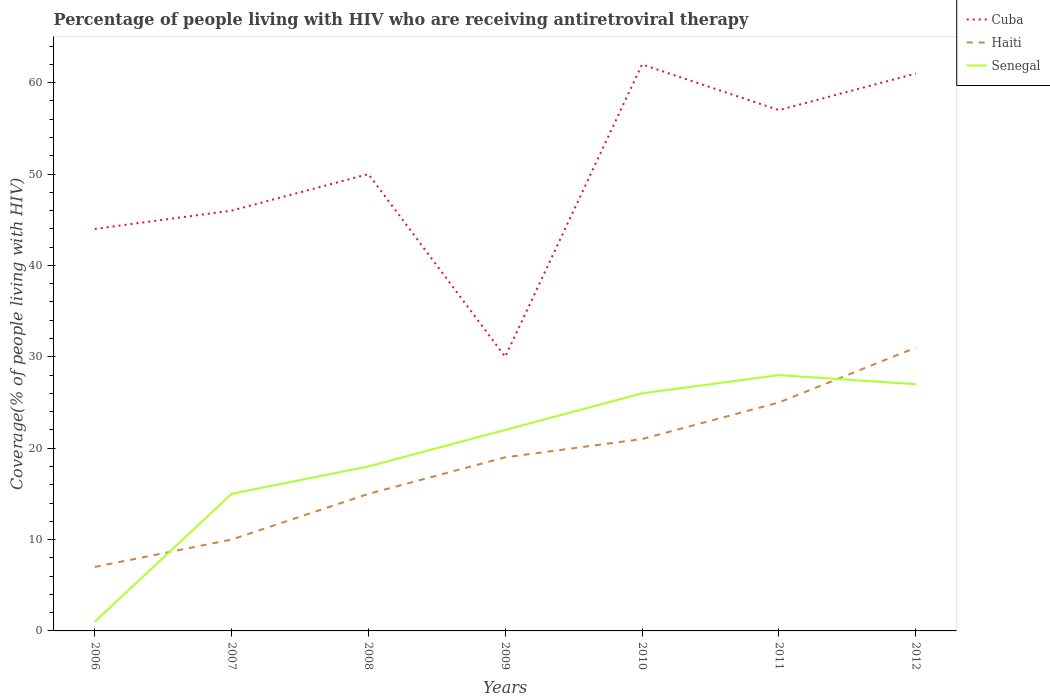Is the number of lines equal to the number of legend labels?
Offer a terse response. Yes. Across all years, what is the maximum percentage of the HIV infected people who are receiving antiretroviral therapy in Haiti?
Offer a very short reply. 7. In which year was the percentage of the HIV infected people who are receiving antiretroviral therapy in Haiti maximum?
Your answer should be compact. 2006. What is the total percentage of the HIV infected people who are receiving antiretroviral therapy in Haiti in the graph?
Provide a succinct answer. -12. What is the difference between the highest and the second highest percentage of the HIV infected people who are receiving antiretroviral therapy in Haiti?
Offer a terse response. 24. Is the percentage of the HIV infected people who are receiving antiretroviral therapy in Cuba strictly greater than the percentage of the HIV infected people who are receiving antiretroviral therapy in Senegal over the years?
Your response must be concise. No. Does the graph contain any zero values?
Provide a succinct answer. No. Does the graph contain grids?
Ensure brevity in your answer.  No. How are the legend labels stacked?
Your answer should be compact. Vertical. What is the title of the graph?
Keep it short and to the point. Percentage of people living with HIV who are receiving antiretroviral therapy. What is the label or title of the Y-axis?
Keep it short and to the point. Coverage(% of people living with HIV). What is the Coverage(% of people living with HIV) of Haiti in 2006?
Your answer should be compact. 7. What is the Coverage(% of people living with HIV) of Senegal in 2007?
Your answer should be very brief. 15. What is the Coverage(% of people living with HIV) of Cuba in 2008?
Offer a very short reply. 50. What is the Coverage(% of people living with HIV) of Haiti in 2008?
Ensure brevity in your answer.  15. What is the Coverage(% of people living with HIV) of Senegal in 2008?
Give a very brief answer. 18. What is the Coverage(% of people living with HIV) in Senegal in 2009?
Your answer should be very brief. 22. What is the Coverage(% of people living with HIV) in Haiti in 2010?
Provide a short and direct response. 21. What is the Coverage(% of people living with HIV) in Cuba in 2011?
Provide a short and direct response. 57. What is the Coverage(% of people living with HIV) in Haiti in 2011?
Keep it short and to the point. 25. What is the Coverage(% of people living with HIV) in Haiti in 2012?
Offer a very short reply. 31. Across all years, what is the maximum Coverage(% of people living with HIV) of Cuba?
Ensure brevity in your answer.  62. Across all years, what is the maximum Coverage(% of people living with HIV) in Senegal?
Provide a short and direct response. 28. Across all years, what is the minimum Coverage(% of people living with HIV) in Cuba?
Ensure brevity in your answer.  30. Across all years, what is the minimum Coverage(% of people living with HIV) in Haiti?
Give a very brief answer. 7. What is the total Coverage(% of people living with HIV) in Cuba in the graph?
Keep it short and to the point. 350. What is the total Coverage(% of people living with HIV) in Haiti in the graph?
Give a very brief answer. 128. What is the total Coverage(% of people living with HIV) of Senegal in the graph?
Your response must be concise. 137. What is the difference between the Coverage(% of people living with HIV) in Senegal in 2006 and that in 2009?
Keep it short and to the point. -21. What is the difference between the Coverage(% of people living with HIV) in Haiti in 2006 and that in 2011?
Make the answer very short. -18. What is the difference between the Coverage(% of people living with HIV) in Cuba in 2006 and that in 2012?
Your response must be concise. -17. What is the difference between the Coverage(% of people living with HIV) of Senegal in 2006 and that in 2012?
Make the answer very short. -26. What is the difference between the Coverage(% of people living with HIV) in Haiti in 2007 and that in 2008?
Your answer should be compact. -5. What is the difference between the Coverage(% of people living with HIV) in Haiti in 2007 and that in 2009?
Your answer should be very brief. -9. What is the difference between the Coverage(% of people living with HIV) of Haiti in 2007 and that in 2010?
Give a very brief answer. -11. What is the difference between the Coverage(% of people living with HIV) of Haiti in 2007 and that in 2011?
Offer a very short reply. -15. What is the difference between the Coverage(% of people living with HIV) of Senegal in 2007 and that in 2011?
Offer a very short reply. -13. What is the difference between the Coverage(% of people living with HIV) in Cuba in 2007 and that in 2012?
Give a very brief answer. -15. What is the difference between the Coverage(% of people living with HIV) of Haiti in 2007 and that in 2012?
Your answer should be very brief. -21. What is the difference between the Coverage(% of people living with HIV) in Senegal in 2007 and that in 2012?
Keep it short and to the point. -12. What is the difference between the Coverage(% of people living with HIV) of Haiti in 2008 and that in 2009?
Give a very brief answer. -4. What is the difference between the Coverage(% of people living with HIV) of Senegal in 2008 and that in 2009?
Offer a terse response. -4. What is the difference between the Coverage(% of people living with HIV) of Cuba in 2008 and that in 2010?
Provide a succinct answer. -12. What is the difference between the Coverage(% of people living with HIV) of Haiti in 2008 and that in 2010?
Your answer should be very brief. -6. What is the difference between the Coverage(% of people living with HIV) in Senegal in 2008 and that in 2010?
Make the answer very short. -8. What is the difference between the Coverage(% of people living with HIV) in Cuba in 2008 and that in 2011?
Your answer should be very brief. -7. What is the difference between the Coverage(% of people living with HIV) of Senegal in 2008 and that in 2011?
Offer a very short reply. -10. What is the difference between the Coverage(% of people living with HIV) of Haiti in 2008 and that in 2012?
Your answer should be very brief. -16. What is the difference between the Coverage(% of people living with HIV) in Senegal in 2008 and that in 2012?
Give a very brief answer. -9. What is the difference between the Coverage(% of people living with HIV) in Cuba in 2009 and that in 2010?
Ensure brevity in your answer.  -32. What is the difference between the Coverage(% of people living with HIV) of Haiti in 2009 and that in 2010?
Make the answer very short. -2. What is the difference between the Coverage(% of people living with HIV) in Senegal in 2009 and that in 2010?
Make the answer very short. -4. What is the difference between the Coverage(% of people living with HIV) in Haiti in 2009 and that in 2011?
Provide a succinct answer. -6. What is the difference between the Coverage(% of people living with HIV) in Senegal in 2009 and that in 2011?
Your answer should be very brief. -6. What is the difference between the Coverage(% of people living with HIV) in Cuba in 2009 and that in 2012?
Make the answer very short. -31. What is the difference between the Coverage(% of people living with HIV) of Haiti in 2010 and that in 2011?
Provide a succinct answer. -4. What is the difference between the Coverage(% of people living with HIV) of Senegal in 2010 and that in 2011?
Make the answer very short. -2. What is the difference between the Coverage(% of people living with HIV) of Cuba in 2010 and that in 2012?
Your answer should be very brief. 1. What is the difference between the Coverage(% of people living with HIV) of Senegal in 2010 and that in 2012?
Offer a terse response. -1. What is the difference between the Coverage(% of people living with HIV) of Cuba in 2011 and that in 2012?
Your response must be concise. -4. What is the difference between the Coverage(% of people living with HIV) of Senegal in 2011 and that in 2012?
Give a very brief answer. 1. What is the difference between the Coverage(% of people living with HIV) of Cuba in 2006 and the Coverage(% of people living with HIV) of Haiti in 2007?
Give a very brief answer. 34. What is the difference between the Coverage(% of people living with HIV) of Haiti in 2006 and the Coverage(% of people living with HIV) of Senegal in 2007?
Your response must be concise. -8. What is the difference between the Coverage(% of people living with HIV) in Haiti in 2006 and the Coverage(% of people living with HIV) in Senegal in 2008?
Offer a very short reply. -11. What is the difference between the Coverage(% of people living with HIV) in Cuba in 2006 and the Coverage(% of people living with HIV) in Haiti in 2009?
Give a very brief answer. 25. What is the difference between the Coverage(% of people living with HIV) of Cuba in 2006 and the Coverage(% of people living with HIV) of Senegal in 2009?
Your answer should be compact. 22. What is the difference between the Coverage(% of people living with HIV) in Haiti in 2006 and the Coverage(% of people living with HIV) in Senegal in 2009?
Offer a very short reply. -15. What is the difference between the Coverage(% of people living with HIV) in Haiti in 2006 and the Coverage(% of people living with HIV) in Senegal in 2010?
Your response must be concise. -19. What is the difference between the Coverage(% of people living with HIV) in Cuba in 2006 and the Coverage(% of people living with HIV) in Haiti in 2011?
Provide a short and direct response. 19. What is the difference between the Coverage(% of people living with HIV) in Haiti in 2006 and the Coverage(% of people living with HIV) in Senegal in 2012?
Your answer should be very brief. -20. What is the difference between the Coverage(% of people living with HIV) of Cuba in 2007 and the Coverage(% of people living with HIV) of Haiti in 2008?
Ensure brevity in your answer.  31. What is the difference between the Coverage(% of people living with HIV) of Haiti in 2007 and the Coverage(% of people living with HIV) of Senegal in 2008?
Keep it short and to the point. -8. What is the difference between the Coverage(% of people living with HIV) of Cuba in 2007 and the Coverage(% of people living with HIV) of Haiti in 2009?
Offer a terse response. 27. What is the difference between the Coverage(% of people living with HIV) of Cuba in 2007 and the Coverage(% of people living with HIV) of Senegal in 2009?
Your answer should be very brief. 24. What is the difference between the Coverage(% of people living with HIV) in Cuba in 2007 and the Coverage(% of people living with HIV) in Senegal in 2010?
Offer a very short reply. 20. What is the difference between the Coverage(% of people living with HIV) of Haiti in 2007 and the Coverage(% of people living with HIV) of Senegal in 2010?
Make the answer very short. -16. What is the difference between the Coverage(% of people living with HIV) in Cuba in 2007 and the Coverage(% of people living with HIV) in Senegal in 2011?
Your response must be concise. 18. What is the difference between the Coverage(% of people living with HIV) in Haiti in 2007 and the Coverage(% of people living with HIV) in Senegal in 2011?
Offer a very short reply. -18. What is the difference between the Coverage(% of people living with HIV) of Cuba in 2007 and the Coverage(% of people living with HIV) of Senegal in 2012?
Offer a very short reply. 19. What is the difference between the Coverage(% of people living with HIV) in Cuba in 2008 and the Coverage(% of people living with HIV) in Haiti in 2009?
Offer a terse response. 31. What is the difference between the Coverage(% of people living with HIV) in Cuba in 2008 and the Coverage(% of people living with HIV) in Haiti in 2010?
Offer a terse response. 29. What is the difference between the Coverage(% of people living with HIV) in Cuba in 2008 and the Coverage(% of people living with HIV) in Senegal in 2010?
Your response must be concise. 24. What is the difference between the Coverage(% of people living with HIV) of Haiti in 2008 and the Coverage(% of people living with HIV) of Senegal in 2010?
Your response must be concise. -11. What is the difference between the Coverage(% of people living with HIV) in Cuba in 2008 and the Coverage(% of people living with HIV) in Haiti in 2011?
Keep it short and to the point. 25. What is the difference between the Coverage(% of people living with HIV) of Cuba in 2008 and the Coverage(% of people living with HIV) of Senegal in 2011?
Ensure brevity in your answer.  22. What is the difference between the Coverage(% of people living with HIV) of Haiti in 2008 and the Coverage(% of people living with HIV) of Senegal in 2011?
Provide a short and direct response. -13. What is the difference between the Coverage(% of people living with HIV) of Cuba in 2008 and the Coverage(% of people living with HIV) of Haiti in 2012?
Give a very brief answer. 19. What is the difference between the Coverage(% of people living with HIV) in Cuba in 2008 and the Coverage(% of people living with HIV) in Senegal in 2012?
Your response must be concise. 23. What is the difference between the Coverage(% of people living with HIV) of Haiti in 2008 and the Coverage(% of people living with HIV) of Senegal in 2012?
Keep it short and to the point. -12. What is the difference between the Coverage(% of people living with HIV) of Cuba in 2009 and the Coverage(% of people living with HIV) of Haiti in 2010?
Give a very brief answer. 9. What is the difference between the Coverage(% of people living with HIV) of Cuba in 2009 and the Coverage(% of people living with HIV) of Senegal in 2011?
Make the answer very short. 2. What is the difference between the Coverage(% of people living with HIV) in Haiti in 2009 and the Coverage(% of people living with HIV) in Senegal in 2011?
Keep it short and to the point. -9. What is the difference between the Coverage(% of people living with HIV) in Cuba in 2010 and the Coverage(% of people living with HIV) in Haiti in 2012?
Offer a very short reply. 31. What is the difference between the Coverage(% of people living with HIV) of Cuba in 2010 and the Coverage(% of people living with HIV) of Senegal in 2012?
Your answer should be very brief. 35. What is the difference between the Coverage(% of people living with HIV) in Haiti in 2010 and the Coverage(% of people living with HIV) in Senegal in 2012?
Your answer should be very brief. -6. What is the difference between the Coverage(% of people living with HIV) of Cuba in 2011 and the Coverage(% of people living with HIV) of Senegal in 2012?
Your answer should be compact. 30. What is the difference between the Coverage(% of people living with HIV) of Haiti in 2011 and the Coverage(% of people living with HIV) of Senegal in 2012?
Offer a terse response. -2. What is the average Coverage(% of people living with HIV) of Haiti per year?
Provide a succinct answer. 18.29. What is the average Coverage(% of people living with HIV) in Senegal per year?
Provide a short and direct response. 19.57. In the year 2006, what is the difference between the Coverage(% of people living with HIV) of Haiti and Coverage(% of people living with HIV) of Senegal?
Your response must be concise. 6. In the year 2007, what is the difference between the Coverage(% of people living with HIV) of Cuba and Coverage(% of people living with HIV) of Haiti?
Give a very brief answer. 36. In the year 2007, what is the difference between the Coverage(% of people living with HIV) in Cuba and Coverage(% of people living with HIV) in Senegal?
Your response must be concise. 31. In the year 2008, what is the difference between the Coverage(% of people living with HIV) in Cuba and Coverage(% of people living with HIV) in Senegal?
Keep it short and to the point. 32. In the year 2009, what is the difference between the Coverage(% of people living with HIV) in Haiti and Coverage(% of people living with HIV) in Senegal?
Provide a succinct answer. -3. In the year 2010, what is the difference between the Coverage(% of people living with HIV) in Cuba and Coverage(% of people living with HIV) in Senegal?
Offer a very short reply. 36. In the year 2012, what is the difference between the Coverage(% of people living with HIV) in Cuba and Coverage(% of people living with HIV) in Senegal?
Give a very brief answer. 34. What is the ratio of the Coverage(% of people living with HIV) in Cuba in 2006 to that in 2007?
Your answer should be very brief. 0.96. What is the ratio of the Coverage(% of people living with HIV) in Senegal in 2006 to that in 2007?
Provide a short and direct response. 0.07. What is the ratio of the Coverage(% of people living with HIV) of Cuba in 2006 to that in 2008?
Your response must be concise. 0.88. What is the ratio of the Coverage(% of people living with HIV) in Haiti in 2006 to that in 2008?
Make the answer very short. 0.47. What is the ratio of the Coverage(% of people living with HIV) in Senegal in 2006 to that in 2008?
Give a very brief answer. 0.06. What is the ratio of the Coverage(% of people living with HIV) of Cuba in 2006 to that in 2009?
Provide a succinct answer. 1.47. What is the ratio of the Coverage(% of people living with HIV) in Haiti in 2006 to that in 2009?
Give a very brief answer. 0.37. What is the ratio of the Coverage(% of people living with HIV) of Senegal in 2006 to that in 2009?
Give a very brief answer. 0.05. What is the ratio of the Coverage(% of people living with HIV) in Cuba in 2006 to that in 2010?
Provide a succinct answer. 0.71. What is the ratio of the Coverage(% of people living with HIV) of Senegal in 2006 to that in 2010?
Offer a very short reply. 0.04. What is the ratio of the Coverage(% of people living with HIV) of Cuba in 2006 to that in 2011?
Make the answer very short. 0.77. What is the ratio of the Coverage(% of people living with HIV) in Haiti in 2006 to that in 2011?
Provide a short and direct response. 0.28. What is the ratio of the Coverage(% of people living with HIV) of Senegal in 2006 to that in 2011?
Your response must be concise. 0.04. What is the ratio of the Coverage(% of people living with HIV) of Cuba in 2006 to that in 2012?
Offer a terse response. 0.72. What is the ratio of the Coverage(% of people living with HIV) of Haiti in 2006 to that in 2012?
Give a very brief answer. 0.23. What is the ratio of the Coverage(% of people living with HIV) in Senegal in 2006 to that in 2012?
Offer a very short reply. 0.04. What is the ratio of the Coverage(% of people living with HIV) in Senegal in 2007 to that in 2008?
Offer a terse response. 0.83. What is the ratio of the Coverage(% of people living with HIV) in Cuba in 2007 to that in 2009?
Ensure brevity in your answer.  1.53. What is the ratio of the Coverage(% of people living with HIV) of Haiti in 2007 to that in 2009?
Offer a terse response. 0.53. What is the ratio of the Coverage(% of people living with HIV) in Senegal in 2007 to that in 2009?
Your answer should be compact. 0.68. What is the ratio of the Coverage(% of people living with HIV) in Cuba in 2007 to that in 2010?
Offer a terse response. 0.74. What is the ratio of the Coverage(% of people living with HIV) of Haiti in 2007 to that in 2010?
Keep it short and to the point. 0.48. What is the ratio of the Coverage(% of people living with HIV) of Senegal in 2007 to that in 2010?
Make the answer very short. 0.58. What is the ratio of the Coverage(% of people living with HIV) in Cuba in 2007 to that in 2011?
Your response must be concise. 0.81. What is the ratio of the Coverage(% of people living with HIV) of Senegal in 2007 to that in 2011?
Keep it short and to the point. 0.54. What is the ratio of the Coverage(% of people living with HIV) of Cuba in 2007 to that in 2012?
Your answer should be compact. 0.75. What is the ratio of the Coverage(% of people living with HIV) in Haiti in 2007 to that in 2012?
Your answer should be compact. 0.32. What is the ratio of the Coverage(% of people living with HIV) in Senegal in 2007 to that in 2012?
Keep it short and to the point. 0.56. What is the ratio of the Coverage(% of people living with HIV) of Haiti in 2008 to that in 2009?
Provide a succinct answer. 0.79. What is the ratio of the Coverage(% of people living with HIV) of Senegal in 2008 to that in 2009?
Your response must be concise. 0.82. What is the ratio of the Coverage(% of people living with HIV) of Cuba in 2008 to that in 2010?
Your response must be concise. 0.81. What is the ratio of the Coverage(% of people living with HIV) in Haiti in 2008 to that in 2010?
Your answer should be compact. 0.71. What is the ratio of the Coverage(% of people living with HIV) of Senegal in 2008 to that in 2010?
Your answer should be very brief. 0.69. What is the ratio of the Coverage(% of people living with HIV) of Cuba in 2008 to that in 2011?
Keep it short and to the point. 0.88. What is the ratio of the Coverage(% of people living with HIV) in Senegal in 2008 to that in 2011?
Keep it short and to the point. 0.64. What is the ratio of the Coverage(% of people living with HIV) in Cuba in 2008 to that in 2012?
Keep it short and to the point. 0.82. What is the ratio of the Coverage(% of people living with HIV) in Haiti in 2008 to that in 2012?
Your response must be concise. 0.48. What is the ratio of the Coverage(% of people living with HIV) of Senegal in 2008 to that in 2012?
Keep it short and to the point. 0.67. What is the ratio of the Coverage(% of people living with HIV) of Cuba in 2009 to that in 2010?
Your response must be concise. 0.48. What is the ratio of the Coverage(% of people living with HIV) in Haiti in 2009 to that in 2010?
Your response must be concise. 0.9. What is the ratio of the Coverage(% of people living with HIV) of Senegal in 2009 to that in 2010?
Your answer should be very brief. 0.85. What is the ratio of the Coverage(% of people living with HIV) in Cuba in 2009 to that in 2011?
Give a very brief answer. 0.53. What is the ratio of the Coverage(% of people living with HIV) in Haiti in 2009 to that in 2011?
Make the answer very short. 0.76. What is the ratio of the Coverage(% of people living with HIV) in Senegal in 2009 to that in 2011?
Offer a terse response. 0.79. What is the ratio of the Coverage(% of people living with HIV) of Cuba in 2009 to that in 2012?
Give a very brief answer. 0.49. What is the ratio of the Coverage(% of people living with HIV) of Haiti in 2009 to that in 2012?
Your answer should be compact. 0.61. What is the ratio of the Coverage(% of people living with HIV) in Senegal in 2009 to that in 2012?
Your answer should be compact. 0.81. What is the ratio of the Coverage(% of people living with HIV) in Cuba in 2010 to that in 2011?
Give a very brief answer. 1.09. What is the ratio of the Coverage(% of people living with HIV) of Haiti in 2010 to that in 2011?
Your answer should be very brief. 0.84. What is the ratio of the Coverage(% of people living with HIV) in Senegal in 2010 to that in 2011?
Ensure brevity in your answer.  0.93. What is the ratio of the Coverage(% of people living with HIV) of Cuba in 2010 to that in 2012?
Offer a terse response. 1.02. What is the ratio of the Coverage(% of people living with HIV) of Haiti in 2010 to that in 2012?
Offer a very short reply. 0.68. What is the ratio of the Coverage(% of people living with HIV) of Senegal in 2010 to that in 2012?
Ensure brevity in your answer.  0.96. What is the ratio of the Coverage(% of people living with HIV) in Cuba in 2011 to that in 2012?
Ensure brevity in your answer.  0.93. What is the ratio of the Coverage(% of people living with HIV) of Haiti in 2011 to that in 2012?
Provide a succinct answer. 0.81. What is the ratio of the Coverage(% of people living with HIV) of Senegal in 2011 to that in 2012?
Provide a succinct answer. 1.04. What is the difference between the highest and the second highest Coverage(% of people living with HIV) of Cuba?
Provide a short and direct response. 1. What is the difference between the highest and the second highest Coverage(% of people living with HIV) in Senegal?
Make the answer very short. 1. What is the difference between the highest and the lowest Coverage(% of people living with HIV) of Cuba?
Your answer should be compact. 32. 